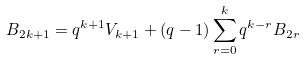Convert formula to latex. <formula><loc_0><loc_0><loc_500><loc_500>B _ { 2 k + 1 } = q ^ { k + 1 } V _ { k + 1 } + ( q - 1 ) \sum _ { r = 0 } ^ { k } q ^ { k - r } B _ { 2 r }</formula> 